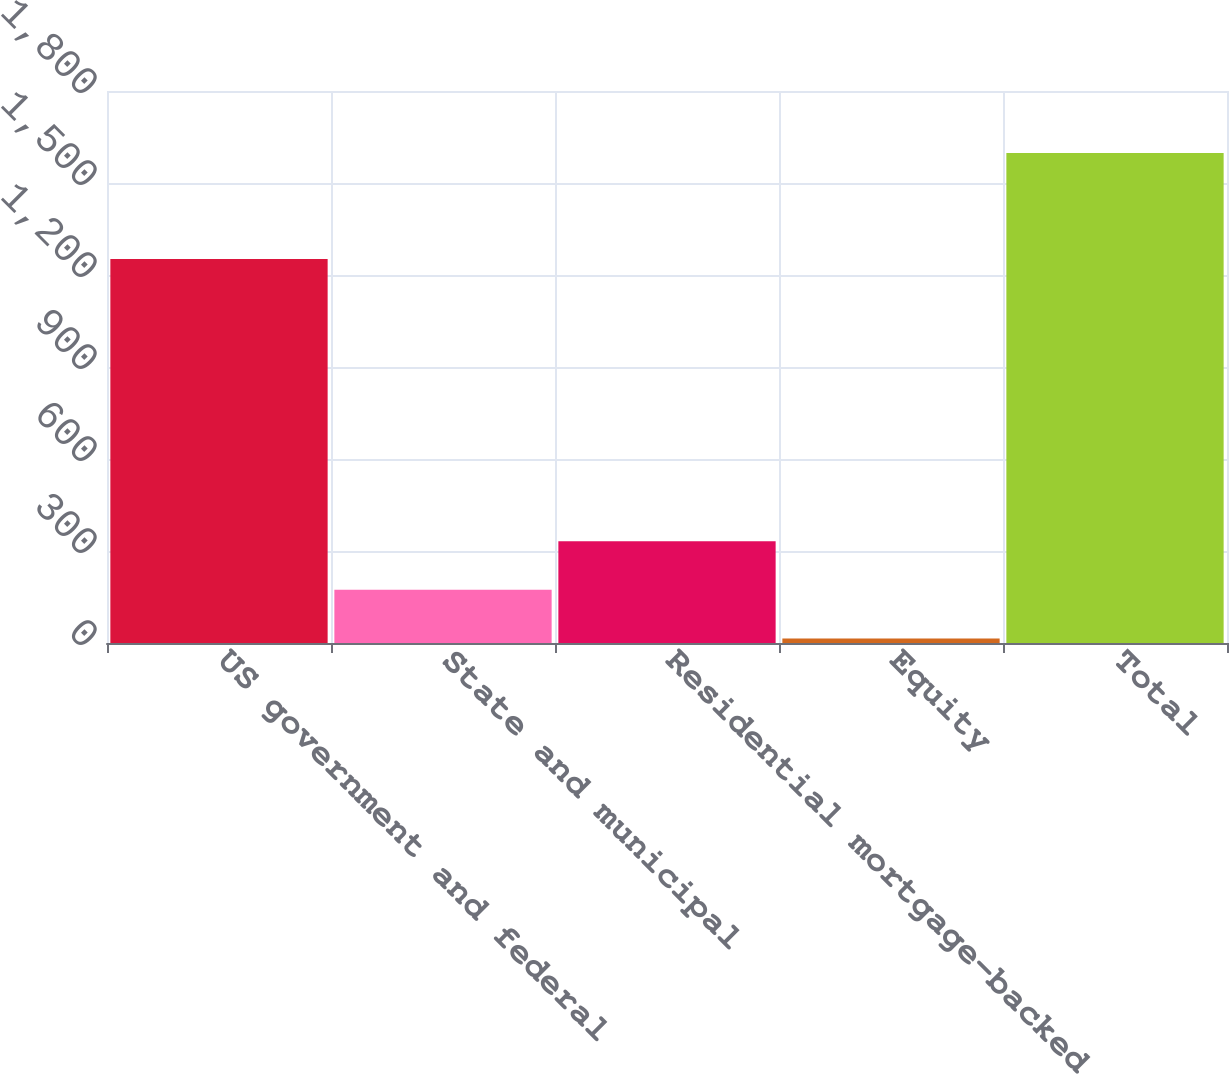Convert chart to OTSL. <chart><loc_0><loc_0><loc_500><loc_500><bar_chart><fcel>US government and federal<fcel>State and municipal<fcel>Residential mortgage-backed<fcel>Equity<fcel>Total<nl><fcel>1252<fcel>173.3<fcel>331.6<fcel>15<fcel>1598<nl></chart> 